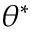<formula> <loc_0><loc_0><loc_500><loc_500>\theta ^ { \ast }</formula> 